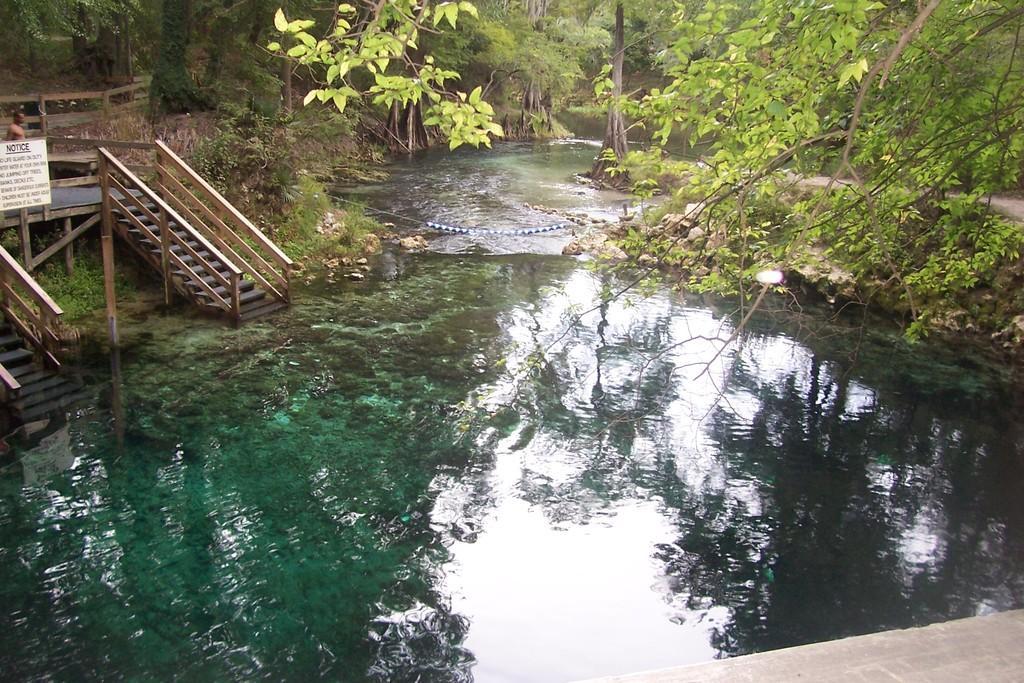Can you describe this image briefly? In this image I can see water, stairs, number of trees, a white board and over there I can see a person. On this board I can see something is written and I can also see reflection in water. 